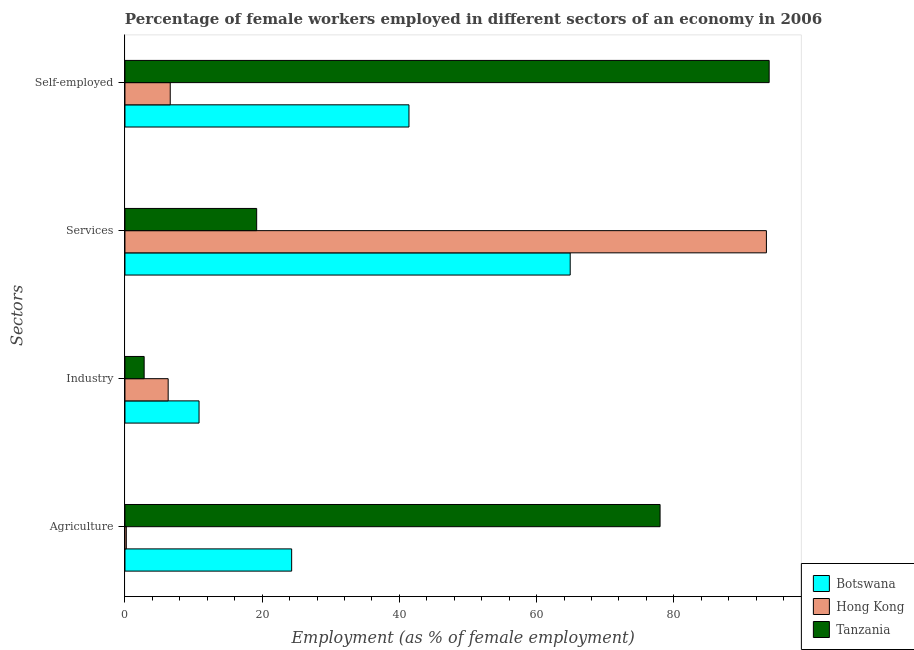How many different coloured bars are there?
Your response must be concise. 3. How many groups of bars are there?
Your answer should be compact. 4. Are the number of bars per tick equal to the number of legend labels?
Give a very brief answer. Yes. How many bars are there on the 1st tick from the top?
Give a very brief answer. 3. What is the label of the 3rd group of bars from the top?
Provide a succinct answer. Industry. What is the percentage of self employed female workers in Tanzania?
Ensure brevity in your answer.  93.9. Across all countries, what is the maximum percentage of self employed female workers?
Ensure brevity in your answer.  93.9. Across all countries, what is the minimum percentage of self employed female workers?
Your answer should be compact. 6.6. In which country was the percentage of self employed female workers maximum?
Ensure brevity in your answer.  Tanzania. In which country was the percentage of female workers in agriculture minimum?
Give a very brief answer. Hong Kong. What is the total percentage of self employed female workers in the graph?
Your response must be concise. 141.9. What is the difference between the percentage of female workers in industry in Botswana and that in Hong Kong?
Provide a succinct answer. 4.5. What is the difference between the percentage of self employed female workers in Hong Kong and the percentage of female workers in agriculture in Tanzania?
Your response must be concise. -71.4. What is the average percentage of female workers in industry per country?
Your response must be concise. 6.63. What is the difference between the percentage of female workers in industry and percentage of self employed female workers in Botswana?
Make the answer very short. -30.6. What is the ratio of the percentage of female workers in agriculture in Tanzania to that in Botswana?
Provide a short and direct response. 3.21. Is the difference between the percentage of female workers in agriculture in Hong Kong and Botswana greater than the difference between the percentage of self employed female workers in Hong Kong and Botswana?
Ensure brevity in your answer.  Yes. What is the difference between the highest and the second highest percentage of female workers in services?
Your response must be concise. 28.6. What is the difference between the highest and the lowest percentage of female workers in agriculture?
Give a very brief answer. 77.8. Is it the case that in every country, the sum of the percentage of female workers in services and percentage of female workers in agriculture is greater than the sum of percentage of female workers in industry and percentage of self employed female workers?
Your answer should be compact. Yes. What does the 2nd bar from the top in Self-employed represents?
Keep it short and to the point. Hong Kong. What does the 3rd bar from the bottom in Agriculture represents?
Provide a short and direct response. Tanzania. Are all the bars in the graph horizontal?
Your response must be concise. Yes. Does the graph contain any zero values?
Provide a short and direct response. No. Does the graph contain grids?
Make the answer very short. No. Where does the legend appear in the graph?
Make the answer very short. Bottom right. How many legend labels are there?
Provide a short and direct response. 3. What is the title of the graph?
Offer a terse response. Percentage of female workers employed in different sectors of an economy in 2006. Does "El Salvador" appear as one of the legend labels in the graph?
Provide a succinct answer. No. What is the label or title of the X-axis?
Provide a short and direct response. Employment (as % of female employment). What is the label or title of the Y-axis?
Your answer should be very brief. Sectors. What is the Employment (as % of female employment) in Botswana in Agriculture?
Provide a short and direct response. 24.3. What is the Employment (as % of female employment) of Hong Kong in Agriculture?
Offer a very short reply. 0.2. What is the Employment (as % of female employment) of Tanzania in Agriculture?
Ensure brevity in your answer.  78. What is the Employment (as % of female employment) of Botswana in Industry?
Provide a short and direct response. 10.8. What is the Employment (as % of female employment) of Hong Kong in Industry?
Your answer should be compact. 6.3. What is the Employment (as % of female employment) of Tanzania in Industry?
Provide a succinct answer. 2.8. What is the Employment (as % of female employment) in Botswana in Services?
Provide a short and direct response. 64.9. What is the Employment (as % of female employment) in Hong Kong in Services?
Give a very brief answer. 93.5. What is the Employment (as % of female employment) in Tanzania in Services?
Your answer should be very brief. 19.2. What is the Employment (as % of female employment) of Botswana in Self-employed?
Make the answer very short. 41.4. What is the Employment (as % of female employment) of Hong Kong in Self-employed?
Keep it short and to the point. 6.6. What is the Employment (as % of female employment) in Tanzania in Self-employed?
Your response must be concise. 93.9. Across all Sectors, what is the maximum Employment (as % of female employment) of Botswana?
Provide a short and direct response. 64.9. Across all Sectors, what is the maximum Employment (as % of female employment) of Hong Kong?
Keep it short and to the point. 93.5. Across all Sectors, what is the maximum Employment (as % of female employment) in Tanzania?
Provide a short and direct response. 93.9. Across all Sectors, what is the minimum Employment (as % of female employment) in Botswana?
Your answer should be compact. 10.8. Across all Sectors, what is the minimum Employment (as % of female employment) in Hong Kong?
Provide a short and direct response. 0.2. Across all Sectors, what is the minimum Employment (as % of female employment) of Tanzania?
Ensure brevity in your answer.  2.8. What is the total Employment (as % of female employment) of Botswana in the graph?
Make the answer very short. 141.4. What is the total Employment (as % of female employment) of Hong Kong in the graph?
Make the answer very short. 106.6. What is the total Employment (as % of female employment) in Tanzania in the graph?
Make the answer very short. 193.9. What is the difference between the Employment (as % of female employment) of Botswana in Agriculture and that in Industry?
Your response must be concise. 13.5. What is the difference between the Employment (as % of female employment) of Tanzania in Agriculture and that in Industry?
Provide a short and direct response. 75.2. What is the difference between the Employment (as % of female employment) of Botswana in Agriculture and that in Services?
Provide a succinct answer. -40.6. What is the difference between the Employment (as % of female employment) of Hong Kong in Agriculture and that in Services?
Ensure brevity in your answer.  -93.3. What is the difference between the Employment (as % of female employment) in Tanzania in Agriculture and that in Services?
Provide a succinct answer. 58.8. What is the difference between the Employment (as % of female employment) of Botswana in Agriculture and that in Self-employed?
Give a very brief answer. -17.1. What is the difference between the Employment (as % of female employment) in Tanzania in Agriculture and that in Self-employed?
Make the answer very short. -15.9. What is the difference between the Employment (as % of female employment) in Botswana in Industry and that in Services?
Provide a succinct answer. -54.1. What is the difference between the Employment (as % of female employment) of Hong Kong in Industry and that in Services?
Offer a very short reply. -87.2. What is the difference between the Employment (as % of female employment) in Tanzania in Industry and that in Services?
Your response must be concise. -16.4. What is the difference between the Employment (as % of female employment) in Botswana in Industry and that in Self-employed?
Provide a short and direct response. -30.6. What is the difference between the Employment (as % of female employment) in Tanzania in Industry and that in Self-employed?
Your response must be concise. -91.1. What is the difference between the Employment (as % of female employment) in Botswana in Services and that in Self-employed?
Provide a short and direct response. 23.5. What is the difference between the Employment (as % of female employment) of Hong Kong in Services and that in Self-employed?
Offer a very short reply. 86.9. What is the difference between the Employment (as % of female employment) of Tanzania in Services and that in Self-employed?
Your answer should be very brief. -74.7. What is the difference between the Employment (as % of female employment) in Botswana in Agriculture and the Employment (as % of female employment) in Hong Kong in Industry?
Provide a succinct answer. 18. What is the difference between the Employment (as % of female employment) of Botswana in Agriculture and the Employment (as % of female employment) of Hong Kong in Services?
Ensure brevity in your answer.  -69.2. What is the difference between the Employment (as % of female employment) in Botswana in Agriculture and the Employment (as % of female employment) in Tanzania in Self-employed?
Provide a short and direct response. -69.6. What is the difference between the Employment (as % of female employment) in Hong Kong in Agriculture and the Employment (as % of female employment) in Tanzania in Self-employed?
Your response must be concise. -93.7. What is the difference between the Employment (as % of female employment) in Botswana in Industry and the Employment (as % of female employment) in Hong Kong in Services?
Keep it short and to the point. -82.7. What is the difference between the Employment (as % of female employment) in Botswana in Industry and the Employment (as % of female employment) in Tanzania in Services?
Ensure brevity in your answer.  -8.4. What is the difference between the Employment (as % of female employment) in Botswana in Industry and the Employment (as % of female employment) in Hong Kong in Self-employed?
Keep it short and to the point. 4.2. What is the difference between the Employment (as % of female employment) of Botswana in Industry and the Employment (as % of female employment) of Tanzania in Self-employed?
Your response must be concise. -83.1. What is the difference between the Employment (as % of female employment) of Hong Kong in Industry and the Employment (as % of female employment) of Tanzania in Self-employed?
Provide a short and direct response. -87.6. What is the difference between the Employment (as % of female employment) of Botswana in Services and the Employment (as % of female employment) of Hong Kong in Self-employed?
Your response must be concise. 58.3. What is the difference between the Employment (as % of female employment) of Botswana in Services and the Employment (as % of female employment) of Tanzania in Self-employed?
Make the answer very short. -29. What is the average Employment (as % of female employment) of Botswana per Sectors?
Provide a succinct answer. 35.35. What is the average Employment (as % of female employment) of Hong Kong per Sectors?
Give a very brief answer. 26.65. What is the average Employment (as % of female employment) of Tanzania per Sectors?
Offer a terse response. 48.48. What is the difference between the Employment (as % of female employment) of Botswana and Employment (as % of female employment) of Hong Kong in Agriculture?
Ensure brevity in your answer.  24.1. What is the difference between the Employment (as % of female employment) of Botswana and Employment (as % of female employment) of Tanzania in Agriculture?
Offer a very short reply. -53.7. What is the difference between the Employment (as % of female employment) of Hong Kong and Employment (as % of female employment) of Tanzania in Agriculture?
Offer a very short reply. -77.8. What is the difference between the Employment (as % of female employment) of Hong Kong and Employment (as % of female employment) of Tanzania in Industry?
Provide a succinct answer. 3.5. What is the difference between the Employment (as % of female employment) of Botswana and Employment (as % of female employment) of Hong Kong in Services?
Ensure brevity in your answer.  -28.6. What is the difference between the Employment (as % of female employment) in Botswana and Employment (as % of female employment) in Tanzania in Services?
Offer a terse response. 45.7. What is the difference between the Employment (as % of female employment) of Hong Kong and Employment (as % of female employment) of Tanzania in Services?
Provide a succinct answer. 74.3. What is the difference between the Employment (as % of female employment) in Botswana and Employment (as % of female employment) in Hong Kong in Self-employed?
Offer a very short reply. 34.8. What is the difference between the Employment (as % of female employment) in Botswana and Employment (as % of female employment) in Tanzania in Self-employed?
Your answer should be compact. -52.5. What is the difference between the Employment (as % of female employment) of Hong Kong and Employment (as % of female employment) of Tanzania in Self-employed?
Keep it short and to the point. -87.3. What is the ratio of the Employment (as % of female employment) in Botswana in Agriculture to that in Industry?
Offer a terse response. 2.25. What is the ratio of the Employment (as % of female employment) in Hong Kong in Agriculture to that in Industry?
Your answer should be compact. 0.03. What is the ratio of the Employment (as % of female employment) in Tanzania in Agriculture to that in Industry?
Give a very brief answer. 27.86. What is the ratio of the Employment (as % of female employment) of Botswana in Agriculture to that in Services?
Keep it short and to the point. 0.37. What is the ratio of the Employment (as % of female employment) in Hong Kong in Agriculture to that in Services?
Make the answer very short. 0. What is the ratio of the Employment (as % of female employment) in Tanzania in Agriculture to that in Services?
Make the answer very short. 4.06. What is the ratio of the Employment (as % of female employment) in Botswana in Agriculture to that in Self-employed?
Make the answer very short. 0.59. What is the ratio of the Employment (as % of female employment) of Hong Kong in Agriculture to that in Self-employed?
Ensure brevity in your answer.  0.03. What is the ratio of the Employment (as % of female employment) of Tanzania in Agriculture to that in Self-employed?
Make the answer very short. 0.83. What is the ratio of the Employment (as % of female employment) in Botswana in Industry to that in Services?
Your response must be concise. 0.17. What is the ratio of the Employment (as % of female employment) of Hong Kong in Industry to that in Services?
Provide a short and direct response. 0.07. What is the ratio of the Employment (as % of female employment) of Tanzania in Industry to that in Services?
Your answer should be very brief. 0.15. What is the ratio of the Employment (as % of female employment) in Botswana in Industry to that in Self-employed?
Offer a very short reply. 0.26. What is the ratio of the Employment (as % of female employment) in Hong Kong in Industry to that in Self-employed?
Keep it short and to the point. 0.95. What is the ratio of the Employment (as % of female employment) of Tanzania in Industry to that in Self-employed?
Offer a very short reply. 0.03. What is the ratio of the Employment (as % of female employment) of Botswana in Services to that in Self-employed?
Your response must be concise. 1.57. What is the ratio of the Employment (as % of female employment) in Hong Kong in Services to that in Self-employed?
Your answer should be compact. 14.17. What is the ratio of the Employment (as % of female employment) of Tanzania in Services to that in Self-employed?
Offer a terse response. 0.2. What is the difference between the highest and the second highest Employment (as % of female employment) of Hong Kong?
Give a very brief answer. 86.9. What is the difference between the highest and the second highest Employment (as % of female employment) of Tanzania?
Offer a very short reply. 15.9. What is the difference between the highest and the lowest Employment (as % of female employment) of Botswana?
Offer a very short reply. 54.1. What is the difference between the highest and the lowest Employment (as % of female employment) of Hong Kong?
Your response must be concise. 93.3. What is the difference between the highest and the lowest Employment (as % of female employment) in Tanzania?
Your answer should be compact. 91.1. 